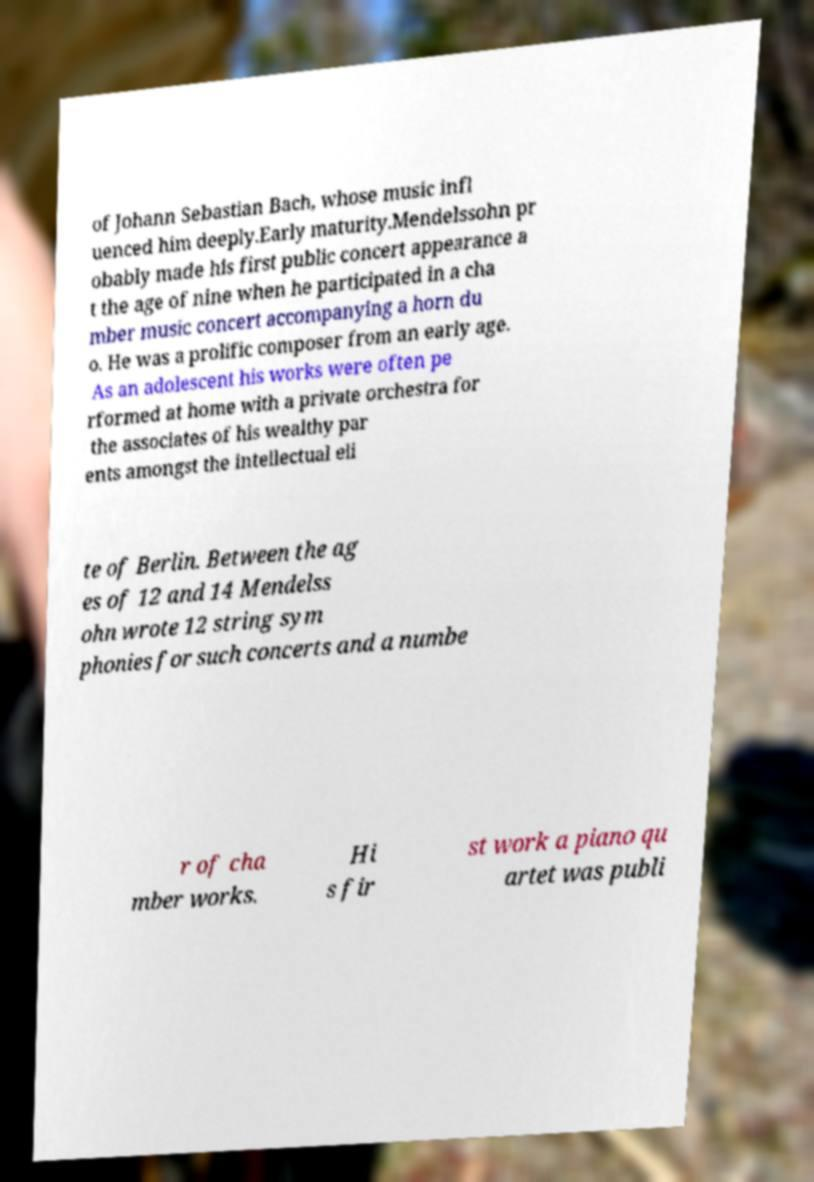Can you accurately transcribe the text from the provided image for me? of Johann Sebastian Bach, whose music infl uenced him deeply.Early maturity.Mendelssohn pr obably made his first public concert appearance a t the age of nine when he participated in a cha mber music concert accompanying a horn du o. He was a prolific composer from an early age. As an adolescent his works were often pe rformed at home with a private orchestra for the associates of his wealthy par ents amongst the intellectual eli te of Berlin. Between the ag es of 12 and 14 Mendelss ohn wrote 12 string sym phonies for such concerts and a numbe r of cha mber works. Hi s fir st work a piano qu artet was publi 